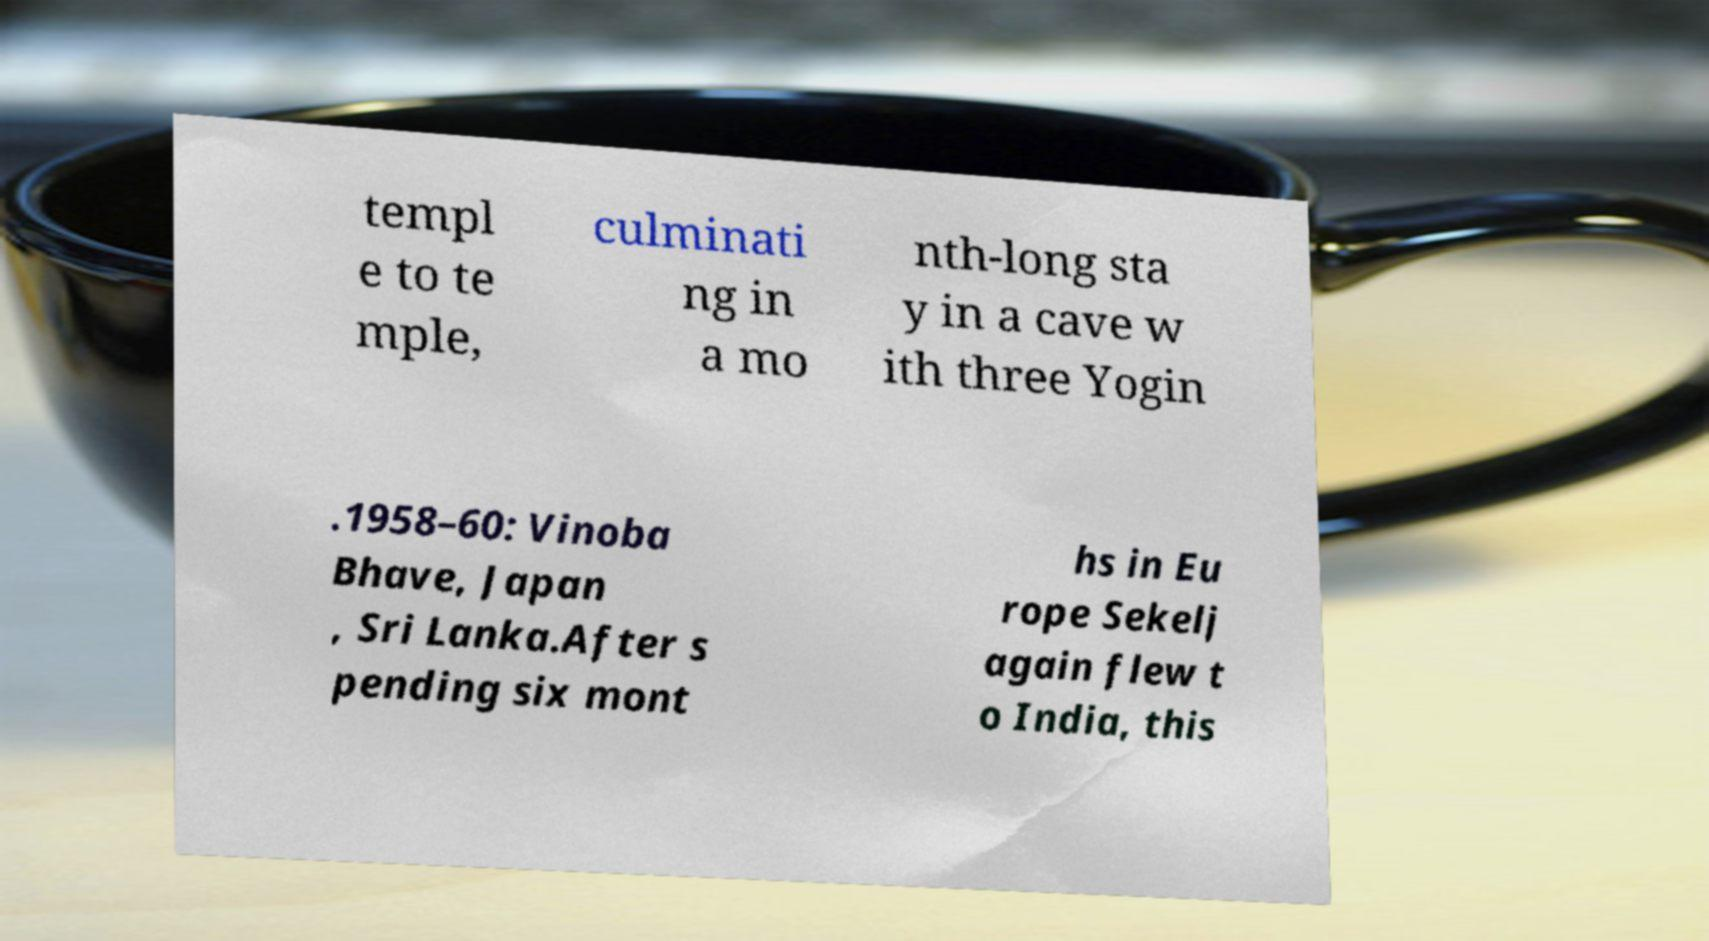Could you extract and type out the text from this image? templ e to te mple, culminati ng in a mo nth-long sta y in a cave w ith three Yogin .1958–60: Vinoba Bhave, Japan , Sri Lanka.After s pending six mont hs in Eu rope Sekelj again flew t o India, this 